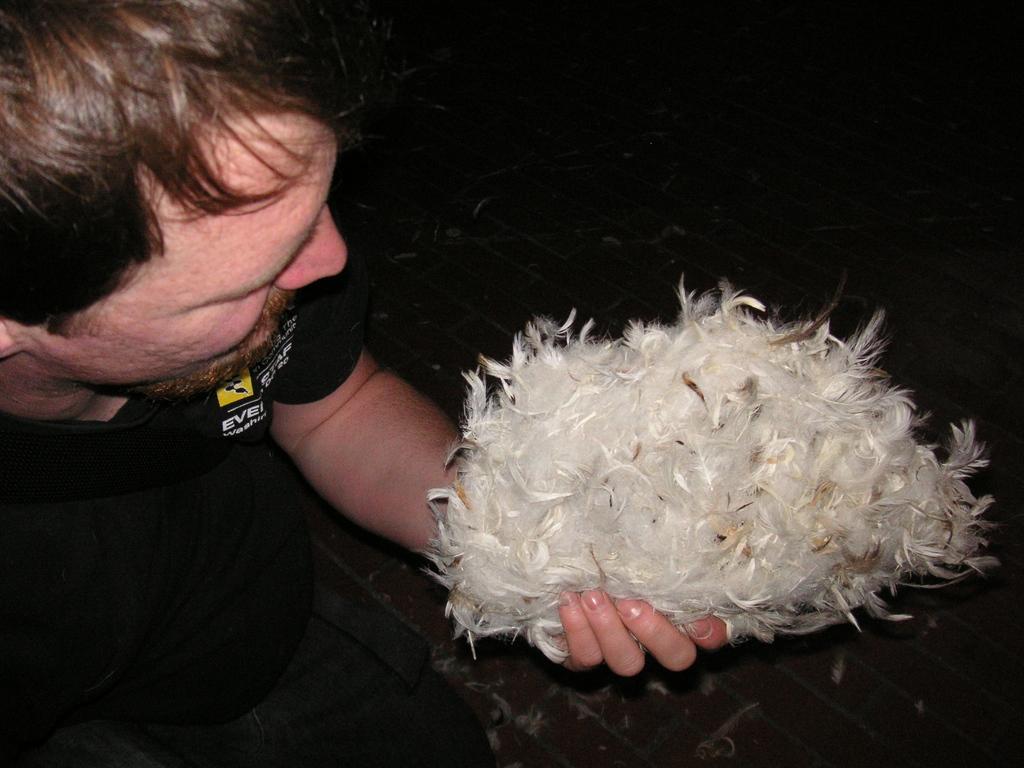In one or two sentences, can you explain what this image depicts? In this image I can see a person holding feathers. He is wearing black t shirt. 